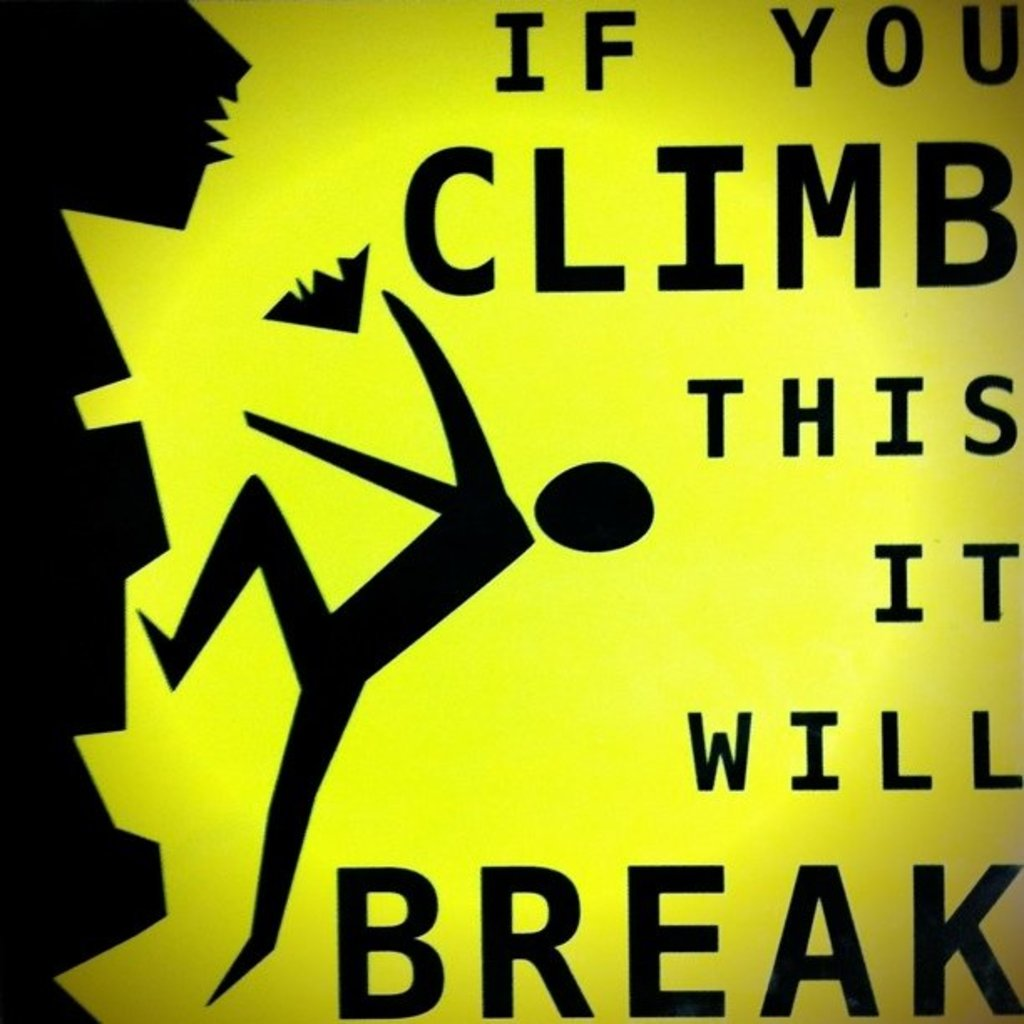Explain the visual content of the image in great detail. The image displays a yellow warning sign featuring a black pictogram of a person in mid-climb. The figure is shown ascending an undefined vertical object, which has broken pieces falling away, suggesting its fragility. Bold, capitalized black text below the figure reads 'IF YOU CLIMB THIS IT WILL BREAK', alerting viewers to the inherent danger and instability of the structure represented. This type of signage is typically used in areas where safety and liability concerns are paramount, such as in construction zones or at public installations. 